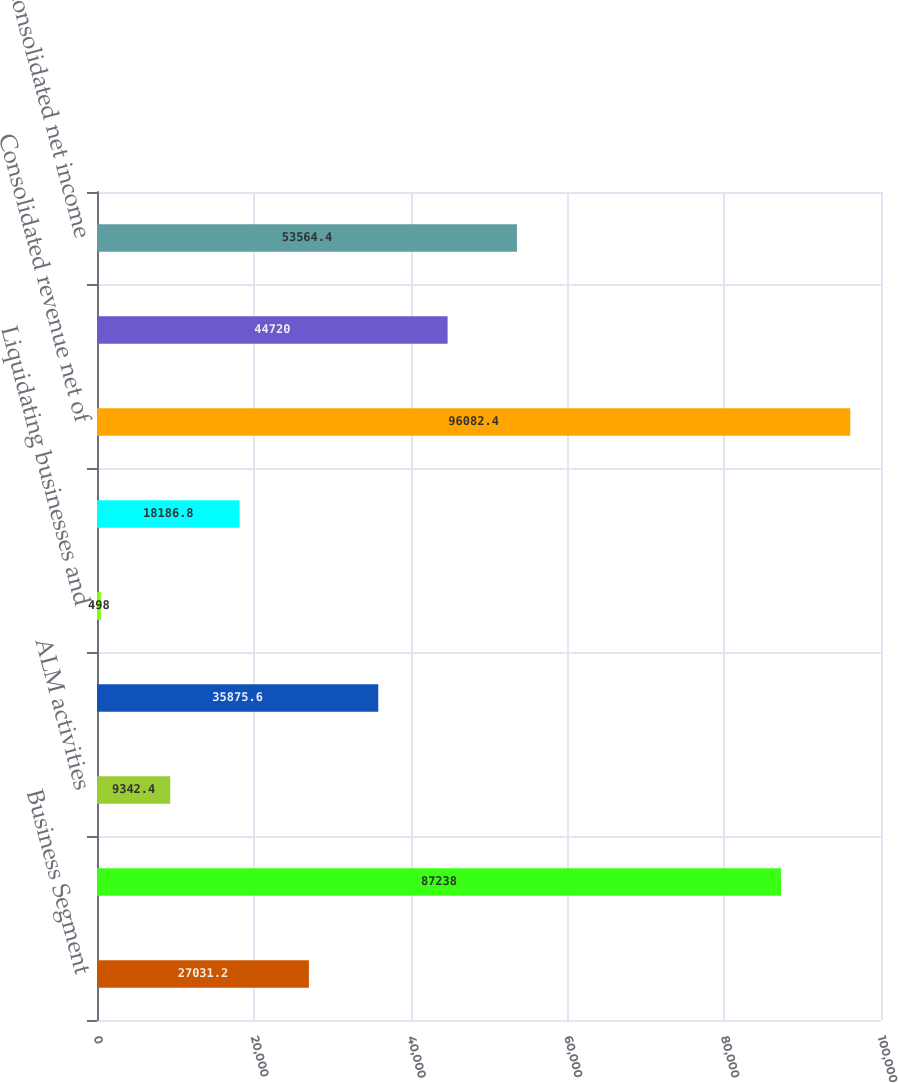<chart> <loc_0><loc_0><loc_500><loc_500><bar_chart><fcel>Business Segment<fcel>Segments' total revenue net of<fcel>ALM activities<fcel>Equity investment income<fcel>Liquidating businesses and<fcel>FTE basis adjustment<fcel>Consolidated revenue net of<fcel>Segments' total net income<fcel>Consolidated net income<nl><fcel>27031.2<fcel>87238<fcel>9342.4<fcel>35875.6<fcel>498<fcel>18186.8<fcel>96082.4<fcel>44720<fcel>53564.4<nl></chart> 